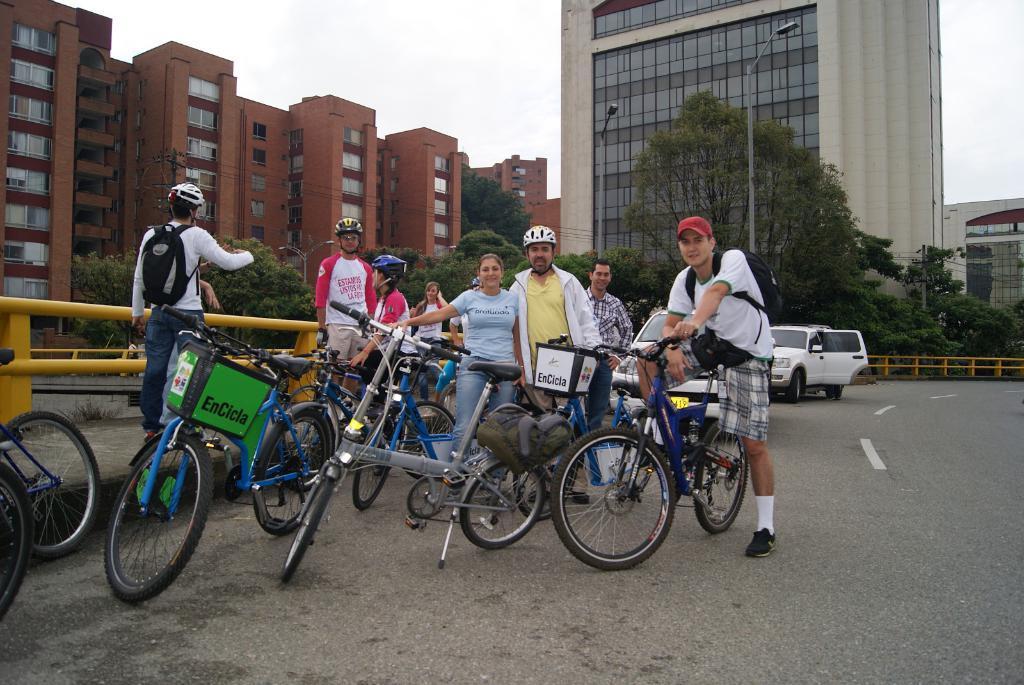Can you describe this image briefly? This picture describe about the group of boys and girl are planning to do the bicycle ride and standing on the bicycle, on the left we can see a boy wearing helmet, white t-shirt and backpack on the back and pointing a hand on the red color building. Beside there is red building we can see a glass mirror building and some tree and street light. On the extreme left we can see a yellow pipe railing and white car parked on the road. 